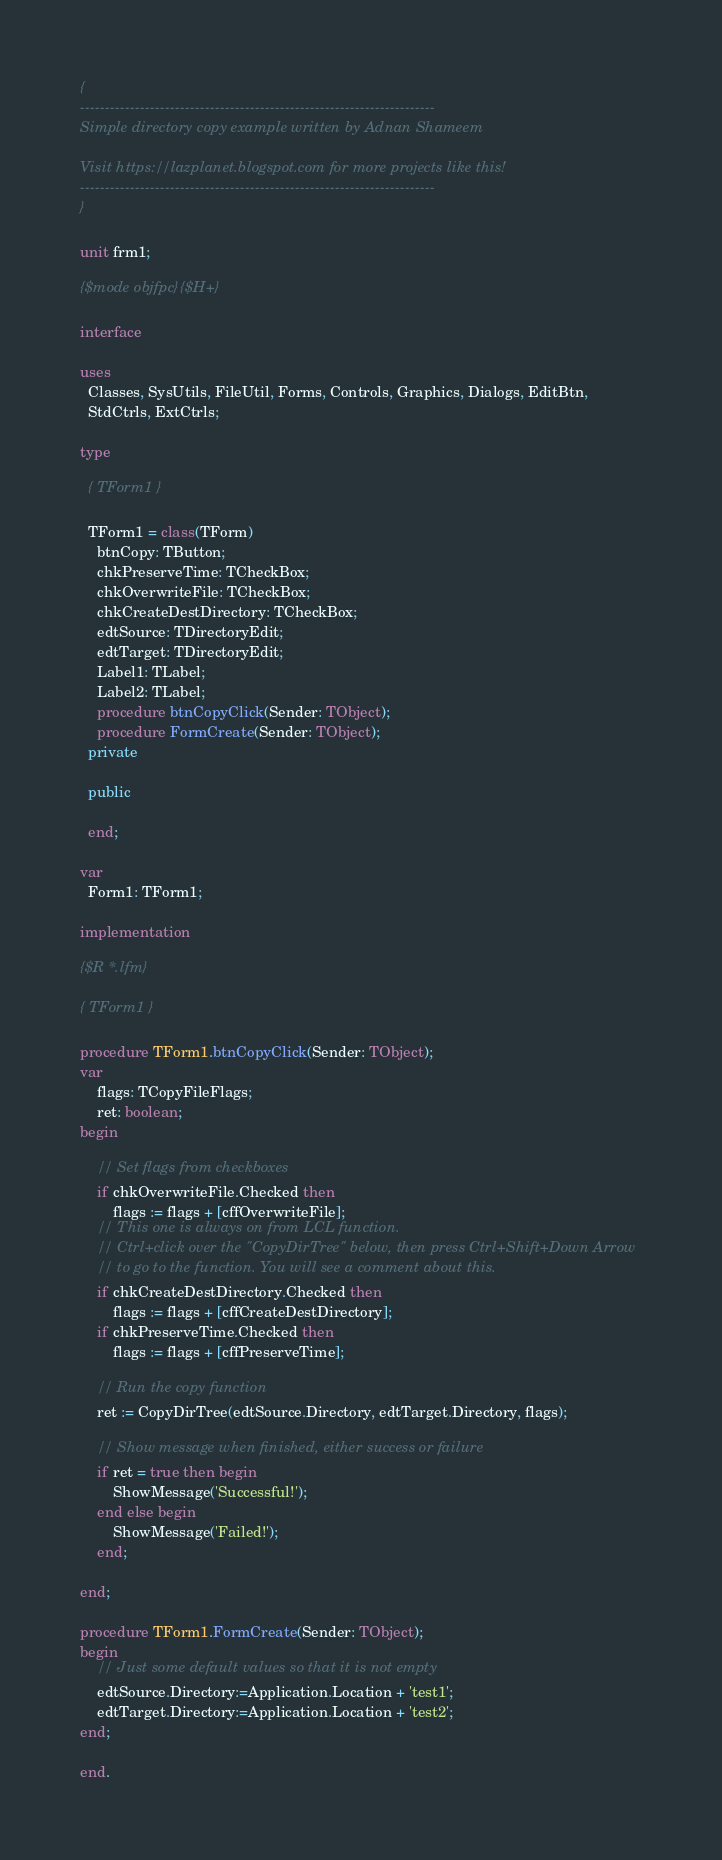<code> <loc_0><loc_0><loc_500><loc_500><_Pascal_>{
-----------------------------------------------------------------------
Simple directory copy example written by Adnan Shameem

Visit https://lazplanet.blogspot.com for more projects like this!
-----------------------------------------------------------------------
}

unit frm1;

{$mode objfpc}{$H+}

interface

uses
  Classes, SysUtils, FileUtil, Forms, Controls, Graphics, Dialogs, EditBtn,
  StdCtrls, ExtCtrls;

type

  { TForm1 }

  TForm1 = class(TForm)
    btnCopy: TButton;
    chkPreserveTime: TCheckBox;
    chkOverwriteFile: TCheckBox;
    chkCreateDestDirectory: TCheckBox;
    edtSource: TDirectoryEdit;
    edtTarget: TDirectoryEdit;
    Label1: TLabel;
    Label2: TLabel;
    procedure btnCopyClick(Sender: TObject);
    procedure FormCreate(Sender: TObject);
  private

  public

  end;

var
  Form1: TForm1;

implementation

{$R *.lfm}

{ TForm1 }

procedure TForm1.btnCopyClick(Sender: TObject);
var
    flags: TCopyFileFlags;
    ret: boolean;
begin

    // Set flags from checkboxes
    if chkOverwriteFile.Checked then
        flags := flags + [cffOverwriteFile];
    // This one is always on from LCL function.
    // Ctrl+click over the "CopyDirTree" below, then press Ctrl+Shift+Down Arrow
    // to go to the function. You will see a comment about this.
    if chkCreateDestDirectory.Checked then
        flags := flags + [cffCreateDestDirectory];
    if chkPreserveTime.Checked then
        flags := flags + [cffPreserveTime];

    // Run the copy function
    ret := CopyDirTree(edtSource.Directory, edtTarget.Directory, flags);

    // Show message when finished, either success or failure
    if ret = true then begin
        ShowMessage('Successful!');
    end else begin
        ShowMessage('Failed!');
    end;

end;

procedure TForm1.FormCreate(Sender: TObject);
begin
    // Just some default values so that it is not empty
    edtSource.Directory:=Application.Location + 'test1';
    edtTarget.Directory:=Application.Location + 'test2';
end;

end.

</code> 